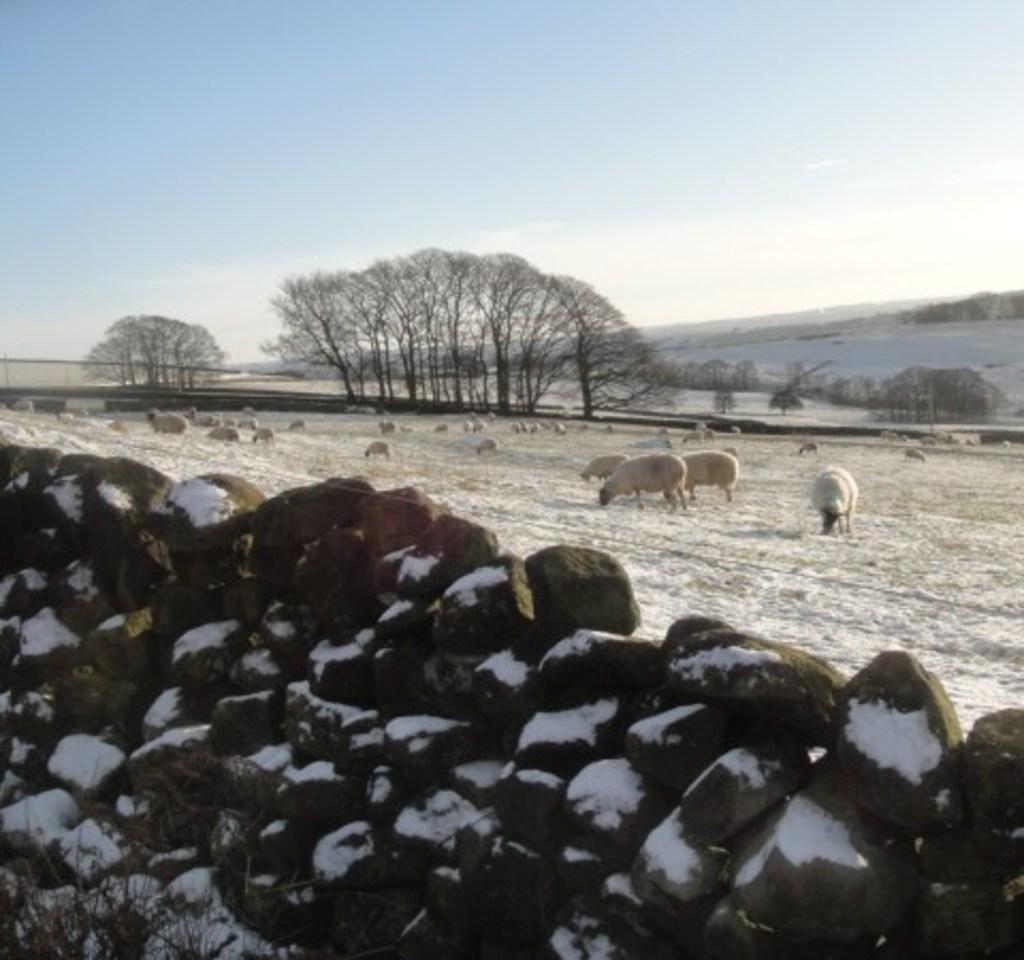How would you summarize this image in a sentence or two? In the image there is a stone wall in the in front with snow on it and behind there are many sheep grazing grass o n the snow land followed by trees behind it along with a hill on the right side and above its sky. 